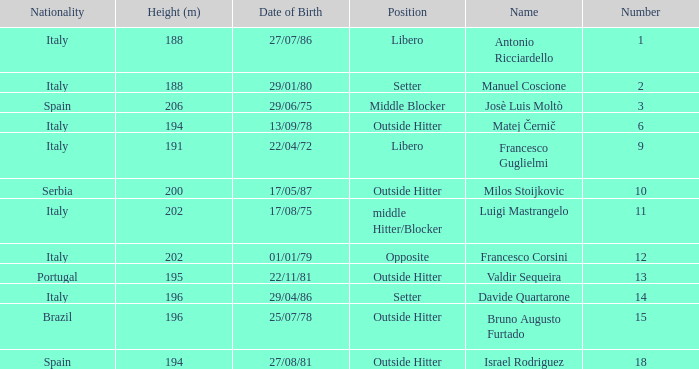Name the height for date of birth being 17/08/75 202.0. 